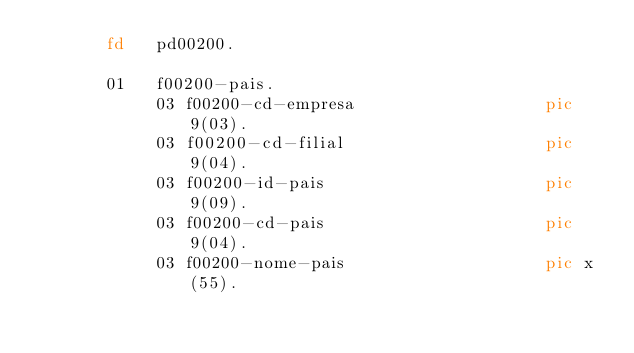<code> <loc_0><loc_0><loc_500><loc_500><_COBOL_>       fd   pd00200.
       
       01   f00200-pais.
            03 f00200-cd-empresa                   pic 9(03).
            03 f00200-cd-filial                    pic 9(04).
            03 f00200-id-pais                      pic 9(09).
            03 f00200-cd-pais                      pic 9(04).
            03 f00200-nome-pais                    pic x(55).
       
      


</code> 